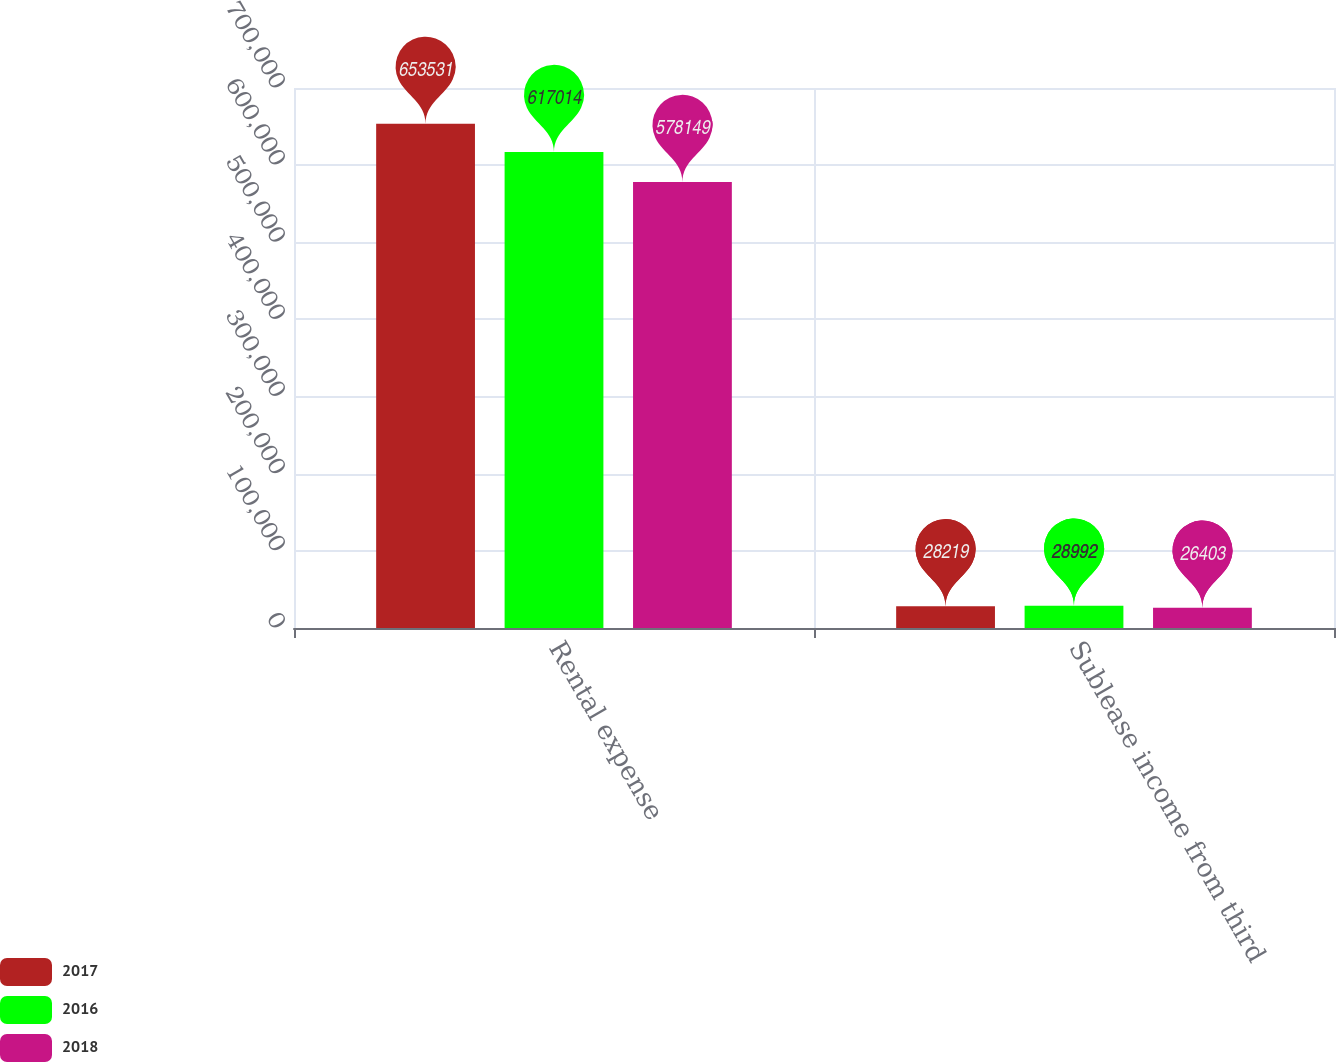Convert chart to OTSL. <chart><loc_0><loc_0><loc_500><loc_500><stacked_bar_chart><ecel><fcel>Rental expense<fcel>Sublease income from third<nl><fcel>2017<fcel>653531<fcel>28219<nl><fcel>2016<fcel>617014<fcel>28992<nl><fcel>2018<fcel>578149<fcel>26403<nl></chart> 